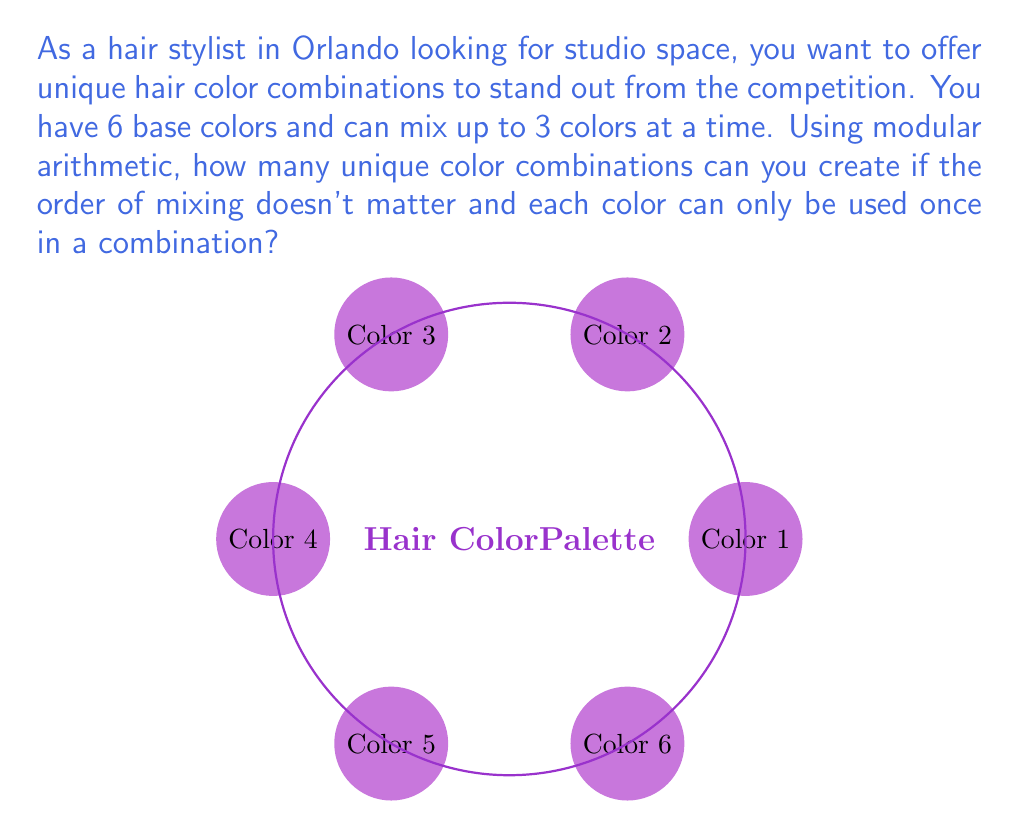Give your solution to this math problem. Let's approach this step-by-step using modular arithmetic and combinatorics:

1) First, we need to calculate the total number of combinations possible when choosing 1, 2, or 3 colors from 6 colors. This is given by the sum of combinations:

   $$\binom{6}{1} + \binom{6}{2} + \binom{6}{3}$$

2) We can calculate each of these:
   $$\binom{6}{1} = 6$$
   $$\binom{6}{2} = \frac{6!}{2!(6-2)!} = 15$$
   $$\binom{6}{3} = \frac{6!}{3!(6-3)!} = 20$$

3) The total sum is:
   $$6 + 15 + 20 = 41$$

4) Now, we need to consider that in modular arithmetic, we're interested in the remainder when dividing by a certain modulus. Let's choose a modulus of 7 (as it's a prime number close to our result).

5) We can express this as:
   $$41 \equiv x \pmod{7}$$

6) To solve this, we divide 41 by 7:
   $$41 = 7 * 5 + 6$$

7) Therefore, the number of unique combinations in modulo 7 is:
   $$x \equiv 6 \pmod{7}$$

This means that when considering the combinations in groups of 7, we have 6 unique combinations left over.
Answer: $6 \pmod{7}$ 